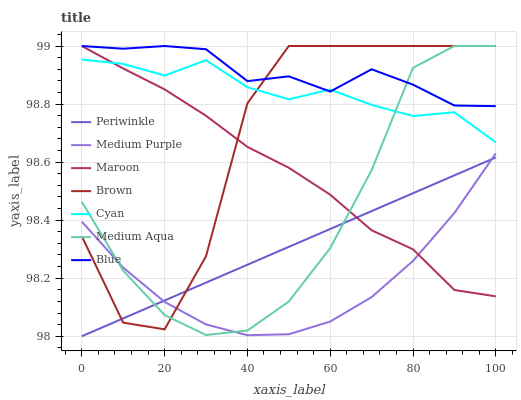Does Medium Purple have the minimum area under the curve?
Answer yes or no. Yes. Does Blue have the maximum area under the curve?
Answer yes or no. Yes. Does Brown have the minimum area under the curve?
Answer yes or no. No. Does Brown have the maximum area under the curve?
Answer yes or no. No. Is Periwinkle the smoothest?
Answer yes or no. Yes. Is Brown the roughest?
Answer yes or no. Yes. Is Maroon the smoothest?
Answer yes or no. No. Is Maroon the roughest?
Answer yes or no. No. Does Periwinkle have the lowest value?
Answer yes or no. Yes. Does Brown have the lowest value?
Answer yes or no. No. Does Medium Aqua have the highest value?
Answer yes or no. Yes. Does Medium Purple have the highest value?
Answer yes or no. No. Is Periwinkle less than Blue?
Answer yes or no. Yes. Is Blue greater than Medium Purple?
Answer yes or no. Yes. Does Periwinkle intersect Medium Aqua?
Answer yes or no. Yes. Is Periwinkle less than Medium Aqua?
Answer yes or no. No. Is Periwinkle greater than Medium Aqua?
Answer yes or no. No. Does Periwinkle intersect Blue?
Answer yes or no. No. 